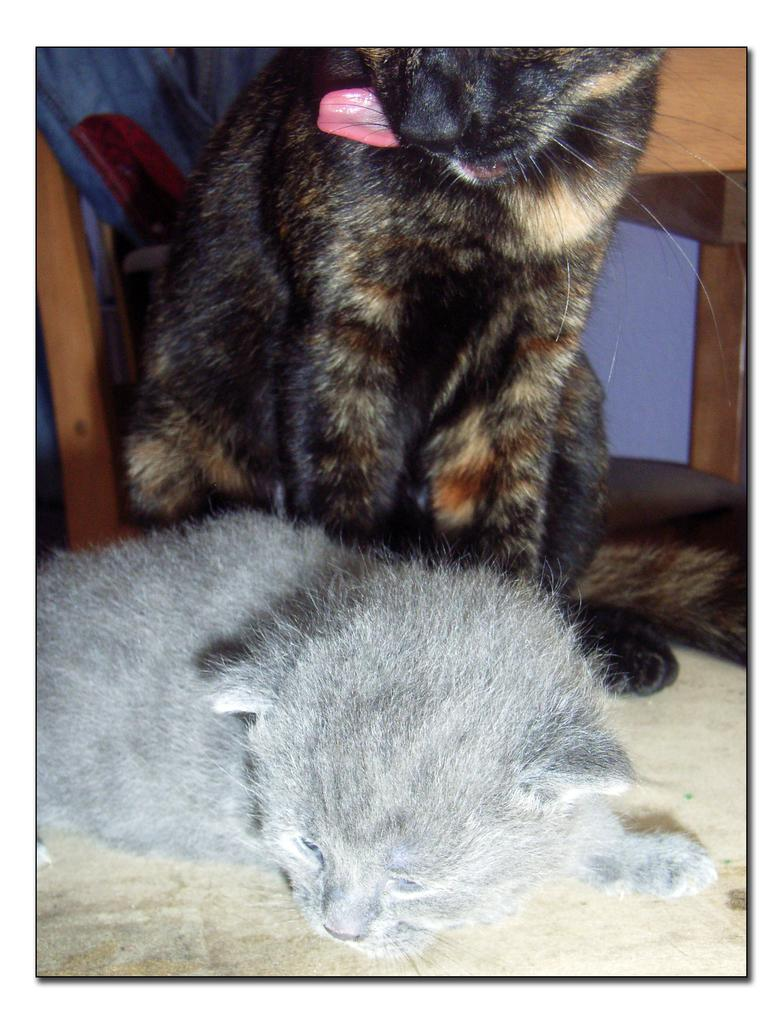How many cats are in the image? There are two cats in the image. Where are the cats located? The cats are on the floor. What else can be seen in the image besides the cats? There are wooden poles in the image. What type of eggs are the cats trying to hatch in the image? There are no eggs present in the image; it features two cats on the floor and wooden poles. 